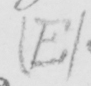What does this handwritten line say? ( E ) 